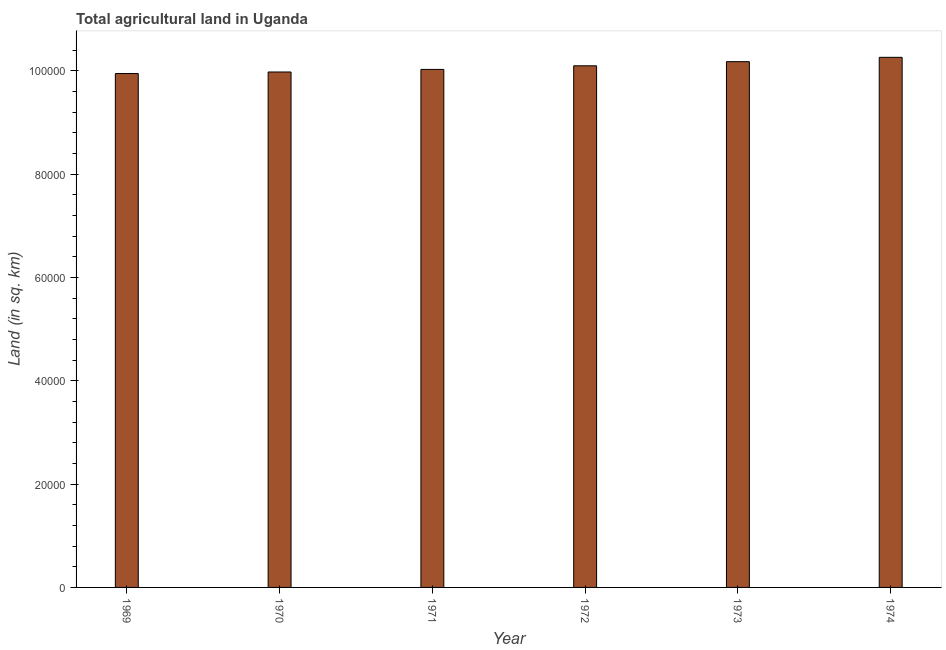Does the graph contain grids?
Offer a terse response. No. What is the title of the graph?
Keep it short and to the point. Total agricultural land in Uganda. What is the label or title of the X-axis?
Give a very brief answer. Year. What is the label or title of the Y-axis?
Offer a very short reply. Land (in sq. km). What is the agricultural land in 1973?
Provide a short and direct response. 1.02e+05. Across all years, what is the maximum agricultural land?
Your answer should be very brief. 1.03e+05. Across all years, what is the minimum agricultural land?
Keep it short and to the point. 9.95e+04. In which year was the agricultural land maximum?
Give a very brief answer. 1974. In which year was the agricultural land minimum?
Your answer should be compact. 1969. What is the sum of the agricultural land?
Give a very brief answer. 6.05e+05. What is the difference between the agricultural land in 1971 and 1972?
Provide a succinct answer. -700. What is the average agricultural land per year?
Offer a very short reply. 1.01e+05. What is the median agricultural land?
Offer a terse response. 1.01e+05. Do a majority of the years between 1972 and 1970 (inclusive) have agricultural land greater than 72000 sq. km?
Make the answer very short. Yes. What is the ratio of the agricultural land in 1971 to that in 1973?
Ensure brevity in your answer.  0.98. Is the difference between the agricultural land in 1971 and 1972 greater than the difference between any two years?
Your answer should be very brief. No. What is the difference between the highest and the second highest agricultural land?
Give a very brief answer. 840. Is the sum of the agricultural land in 1970 and 1974 greater than the maximum agricultural land across all years?
Offer a terse response. Yes. What is the difference between the highest and the lowest agricultural land?
Offer a terse response. 3140. In how many years, is the agricultural land greater than the average agricultural land taken over all years?
Your response must be concise. 3. Are all the bars in the graph horizontal?
Make the answer very short. No. How many years are there in the graph?
Your answer should be very brief. 6. What is the difference between two consecutive major ticks on the Y-axis?
Keep it short and to the point. 2.00e+04. Are the values on the major ticks of Y-axis written in scientific E-notation?
Ensure brevity in your answer.  No. What is the Land (in sq. km) in 1969?
Provide a succinct answer. 9.95e+04. What is the Land (in sq. km) in 1970?
Your response must be concise. 9.98e+04. What is the Land (in sq. km) of 1971?
Keep it short and to the point. 1.00e+05. What is the Land (in sq. km) of 1972?
Offer a very short reply. 1.01e+05. What is the Land (in sq. km) in 1973?
Keep it short and to the point. 1.02e+05. What is the Land (in sq. km) of 1974?
Provide a succinct answer. 1.03e+05. What is the difference between the Land (in sq. km) in 1969 and 1970?
Offer a very short reply. -300. What is the difference between the Land (in sq. km) in 1969 and 1971?
Your answer should be very brief. -800. What is the difference between the Land (in sq. km) in 1969 and 1972?
Offer a very short reply. -1500. What is the difference between the Land (in sq. km) in 1969 and 1973?
Your response must be concise. -2300. What is the difference between the Land (in sq. km) in 1969 and 1974?
Keep it short and to the point. -3140. What is the difference between the Land (in sq. km) in 1970 and 1971?
Provide a short and direct response. -500. What is the difference between the Land (in sq. km) in 1970 and 1972?
Ensure brevity in your answer.  -1200. What is the difference between the Land (in sq. km) in 1970 and 1973?
Provide a succinct answer. -2000. What is the difference between the Land (in sq. km) in 1970 and 1974?
Keep it short and to the point. -2840. What is the difference between the Land (in sq. km) in 1971 and 1972?
Your answer should be very brief. -700. What is the difference between the Land (in sq. km) in 1971 and 1973?
Keep it short and to the point. -1500. What is the difference between the Land (in sq. km) in 1971 and 1974?
Offer a very short reply. -2340. What is the difference between the Land (in sq. km) in 1972 and 1973?
Offer a very short reply. -800. What is the difference between the Land (in sq. km) in 1972 and 1974?
Keep it short and to the point. -1640. What is the difference between the Land (in sq. km) in 1973 and 1974?
Give a very brief answer. -840. What is the ratio of the Land (in sq. km) in 1969 to that in 1971?
Provide a short and direct response. 0.99. What is the ratio of the Land (in sq. km) in 1969 to that in 1972?
Offer a very short reply. 0.98. What is the ratio of the Land (in sq. km) in 1969 to that in 1973?
Keep it short and to the point. 0.98. What is the ratio of the Land (in sq. km) in 1970 to that in 1971?
Offer a terse response. 0.99. What is the ratio of the Land (in sq. km) in 1970 to that in 1973?
Provide a short and direct response. 0.98. What is the ratio of the Land (in sq. km) in 1970 to that in 1974?
Give a very brief answer. 0.97. What is the ratio of the Land (in sq. km) in 1971 to that in 1972?
Your response must be concise. 0.99. What is the ratio of the Land (in sq. km) in 1971 to that in 1974?
Give a very brief answer. 0.98. What is the ratio of the Land (in sq. km) in 1972 to that in 1973?
Your answer should be compact. 0.99. 